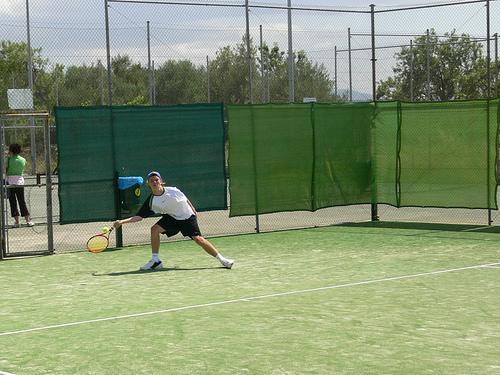How many zebras are in the image?
Give a very brief answer. 0. 